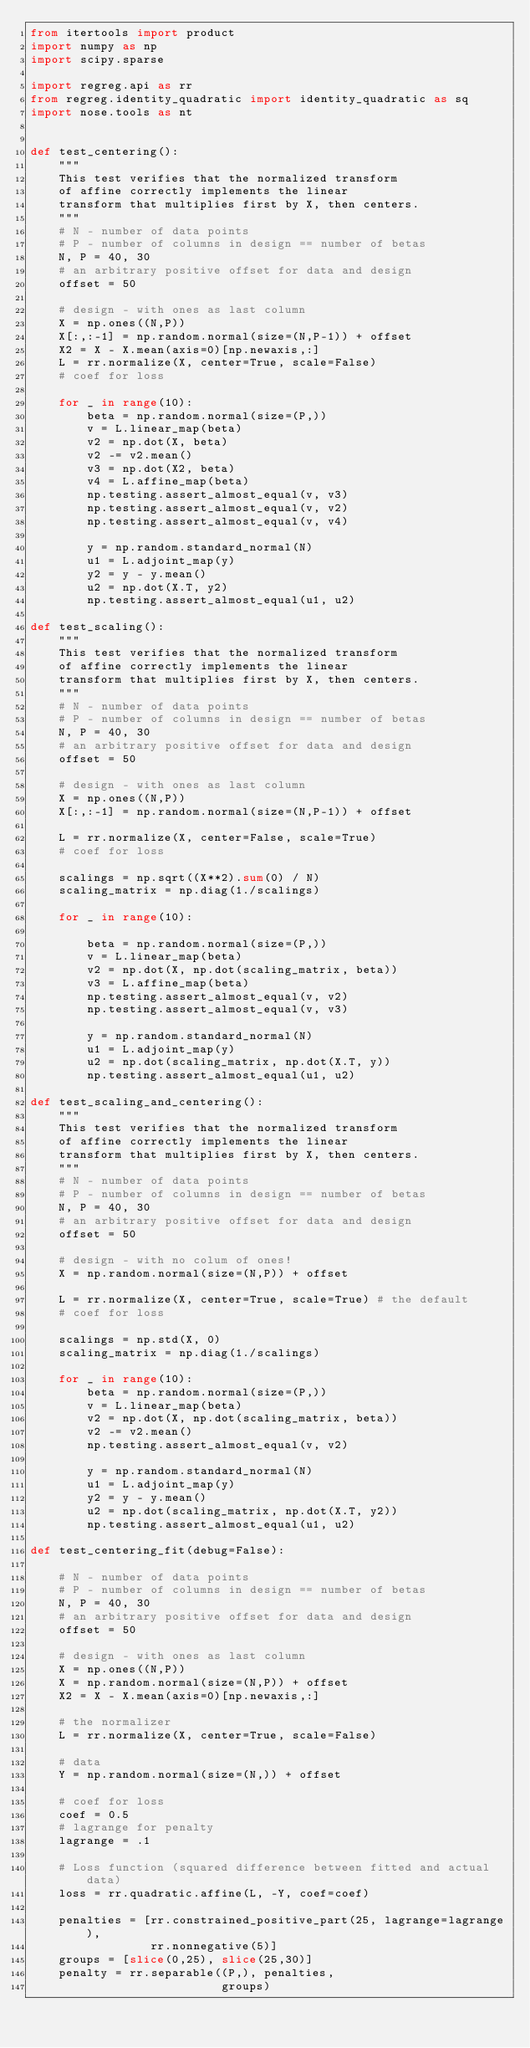Convert code to text. <code><loc_0><loc_0><loc_500><loc_500><_Python_>from itertools import product
import numpy as np
import scipy.sparse

import regreg.api as rr
from regreg.identity_quadratic import identity_quadratic as sq
import nose.tools as nt


def test_centering():
    """
    This test verifies that the normalized transform
    of affine correctly implements the linear
    transform that multiplies first by X, then centers.
    """
    # N - number of data points
    # P - number of columns in design == number of betas
    N, P = 40, 30
    # an arbitrary positive offset for data and design
    offset = 50

    # design - with ones as last column
    X = np.ones((N,P))
    X[:,:-1] = np.random.normal(size=(N,P-1)) + offset
    X2 = X - X.mean(axis=0)[np.newaxis,:]
    L = rr.normalize(X, center=True, scale=False)
    # coef for loss

    for _ in range(10):
        beta = np.random.normal(size=(P,))
        v = L.linear_map(beta)
        v2 = np.dot(X, beta)
        v2 -= v2.mean()
        v3 = np.dot(X2, beta)
        v4 = L.affine_map(beta)
        np.testing.assert_almost_equal(v, v3)
        np.testing.assert_almost_equal(v, v2)
        np.testing.assert_almost_equal(v, v4)

        y = np.random.standard_normal(N)
        u1 = L.adjoint_map(y)
        y2 = y - y.mean()
        u2 = np.dot(X.T, y2)
        np.testing.assert_almost_equal(u1, u2)

def test_scaling():
    """
    This test verifies that the normalized transform
    of affine correctly implements the linear
    transform that multiplies first by X, then centers.
    """
    # N - number of data points
    # P - number of columns in design == number of betas
    N, P = 40, 30
    # an arbitrary positive offset for data and design
    offset = 50

    # design - with ones as last column
    X = np.ones((N,P))
    X[:,:-1] = np.random.normal(size=(N,P-1)) + offset

    L = rr.normalize(X, center=False, scale=True)
    # coef for loss

    scalings = np.sqrt((X**2).sum(0) / N)
    scaling_matrix = np.diag(1./scalings)
    
    for _ in range(10):

        beta = np.random.normal(size=(P,))
        v = L.linear_map(beta)
        v2 = np.dot(X, np.dot(scaling_matrix, beta))
        v3 = L.affine_map(beta)
        np.testing.assert_almost_equal(v, v2)
        np.testing.assert_almost_equal(v, v3)

        y = np.random.standard_normal(N)
        u1 = L.adjoint_map(y)
        u2 = np.dot(scaling_matrix, np.dot(X.T, y))
        np.testing.assert_almost_equal(u1, u2)

def test_scaling_and_centering():
    """
    This test verifies that the normalized transform
    of affine correctly implements the linear
    transform that multiplies first by X, then centers.
    """
    # N - number of data points
    # P - number of columns in design == number of betas
    N, P = 40, 30
    # an arbitrary positive offset for data and design
    offset = 50

    # design - with no colum of ones!
    X = np.random.normal(size=(N,P)) + offset

    L = rr.normalize(X, center=True, scale=True) # the default
    # coef for loss

    scalings = np.std(X, 0)
    scaling_matrix = np.diag(1./scalings)

    for _ in range(10):
        beta = np.random.normal(size=(P,))
        v = L.linear_map(beta)
        v2 = np.dot(X, np.dot(scaling_matrix, beta))
        v2 -= v2.mean()
        np.testing.assert_almost_equal(v, v2)

        y = np.random.standard_normal(N)
        u1 = L.adjoint_map(y)
        y2 = y - y.mean()
        u2 = np.dot(scaling_matrix, np.dot(X.T, y2))
        np.testing.assert_almost_equal(u1, u2)

def test_centering_fit(debug=False):

    # N - number of data points
    # P - number of columns in design == number of betas
    N, P = 40, 30
    # an arbitrary positive offset for data and design
    offset = 50

    # design - with ones as last column
    X = np.ones((N,P))
    X = np.random.normal(size=(N,P)) + offset
    X2 = X - X.mean(axis=0)[np.newaxis,:]

    # the normalizer
    L = rr.normalize(X, center=True, scale=False)

    # data
    Y = np.random.normal(size=(N,)) + offset

    # coef for loss
    coef = 0.5
    # lagrange for penalty
    lagrange = .1

    # Loss function (squared difference between fitted and actual data)
    loss = rr.quadratic.affine(L, -Y, coef=coef)

    penalties = [rr.constrained_positive_part(25, lagrange=lagrange),
                 rr.nonnegative(5)]
    groups = [slice(0,25), slice(25,30)]
    penalty = rr.separable((P,), penalties,
                           groups)</code> 